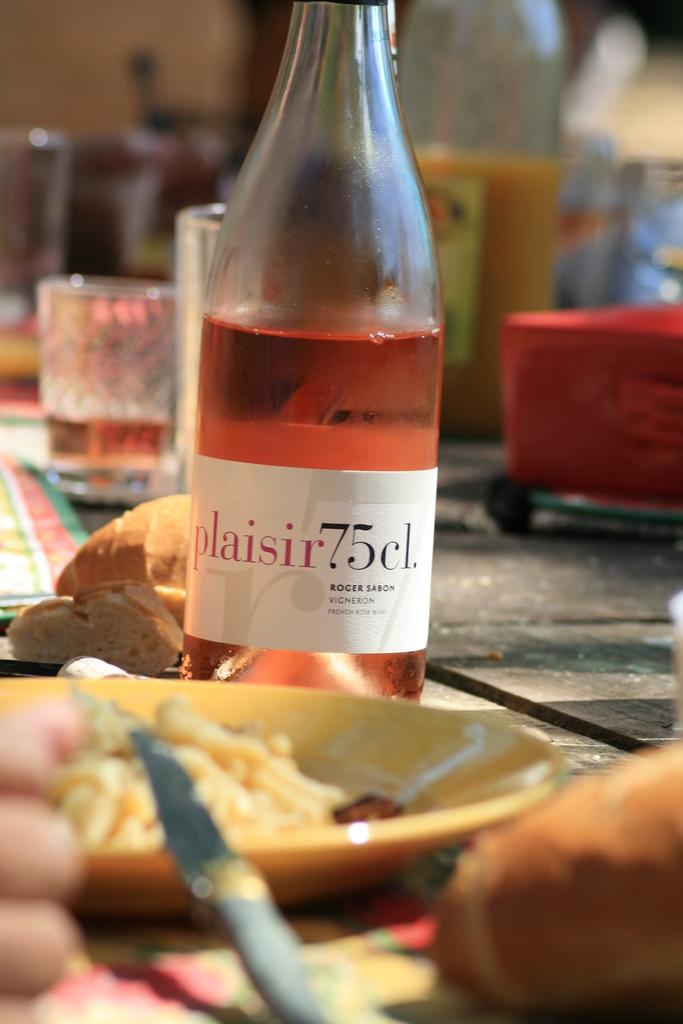What specific number does the wine mention?
Give a very brief answer. 75. 